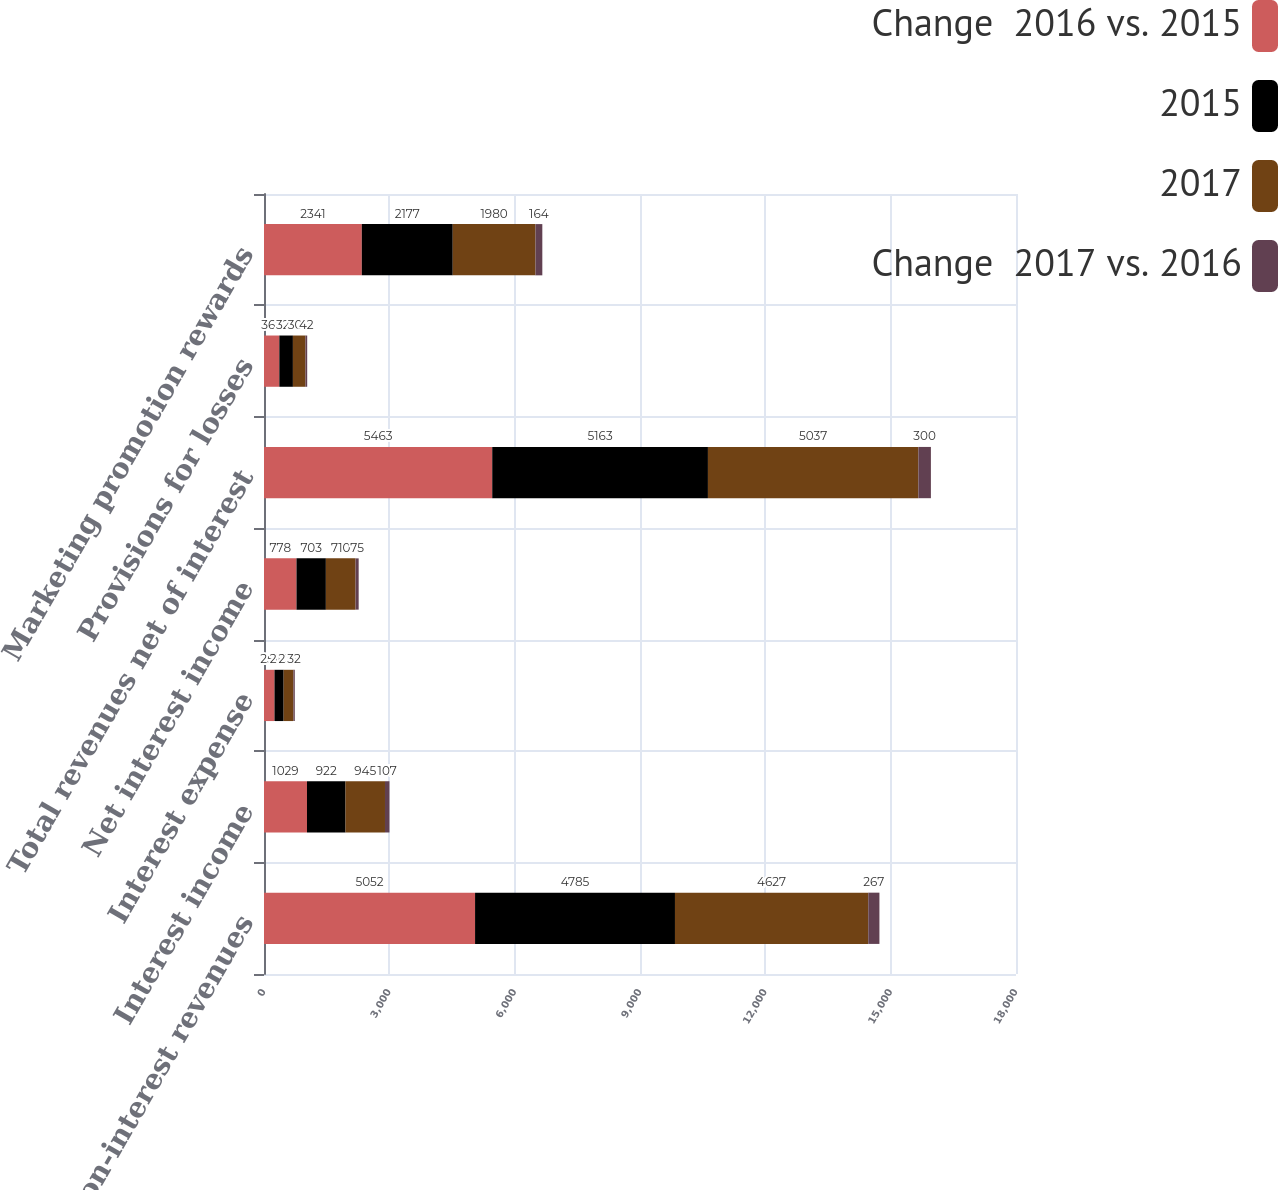Convert chart. <chart><loc_0><loc_0><loc_500><loc_500><stacked_bar_chart><ecel><fcel>Non-interest revenues<fcel>Interest income<fcel>Interest expense<fcel>Net interest income<fcel>Total revenues net of interest<fcel>Provisions for losses<fcel>Marketing promotion rewards<nl><fcel>Change  2016 vs. 2015<fcel>5052<fcel>1029<fcel>251<fcel>778<fcel>5463<fcel>367<fcel>2341<nl><fcel>2015<fcel>4785<fcel>922<fcel>219<fcel>703<fcel>5163<fcel>325<fcel>2177<nl><fcel>2017<fcel>4627<fcel>945<fcel>235<fcel>710<fcel>5037<fcel>300<fcel>1980<nl><fcel>Change  2017 vs. 2016<fcel>267<fcel>107<fcel>32<fcel>75<fcel>300<fcel>42<fcel>164<nl></chart> 